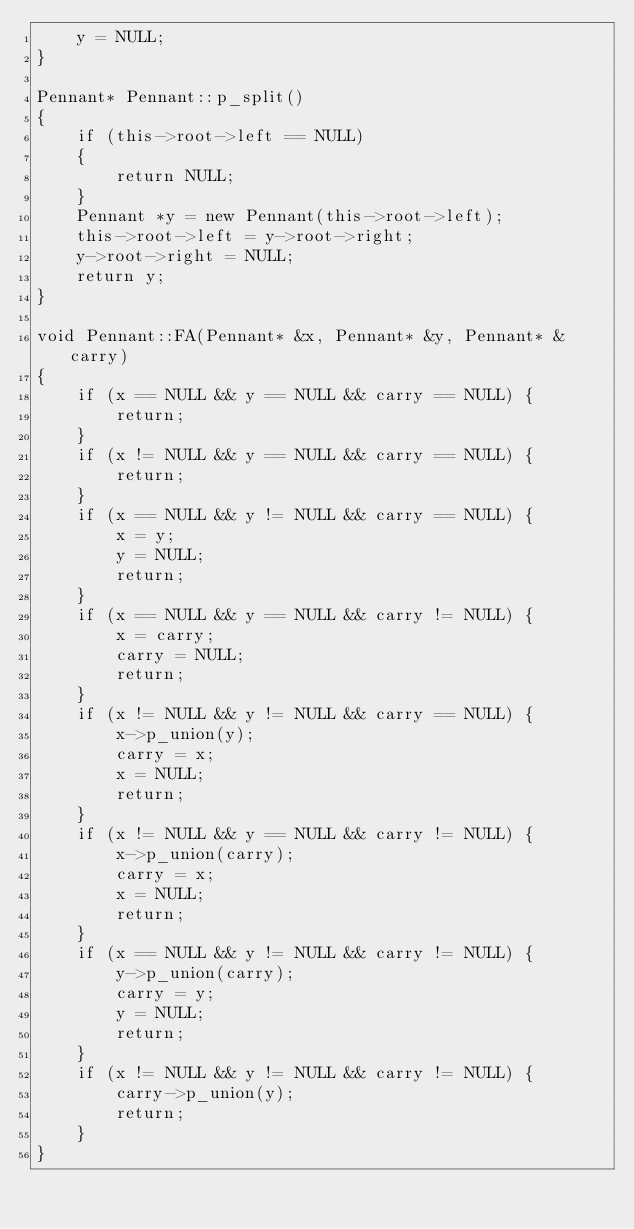<code> <loc_0><loc_0><loc_500><loc_500><_C++_>	y = NULL;
}

Pennant* Pennant::p_split()
{
	if (this->root->left == NULL)
	{
		return NULL;
	}
	Pennant *y = new Pennant(this->root->left);
	this->root->left = y->root->right;
	y->root->right = NULL;
	return y;
}

void Pennant::FA(Pennant* &x, Pennant* &y, Pennant* &carry)
{
	if (x == NULL && y == NULL && carry == NULL) {
		return;
	}
	if (x != NULL && y == NULL && carry == NULL) {
		return;
	}
	if (x == NULL && y != NULL && carry == NULL) {
		x = y;
		y = NULL;
		return;
	}
	if (x == NULL && y == NULL && carry != NULL) {
		x = carry;
		carry = NULL;
		return;
	}
	if (x != NULL && y != NULL && carry == NULL) {
		x->p_union(y);
		carry = x;
		x = NULL;
		return;
	}
	if (x != NULL && y == NULL && carry != NULL) {
		x->p_union(carry);
		carry = x;
		x = NULL;
		return;
	}
	if (x == NULL && y != NULL && carry != NULL) {
		y->p_union(carry);
		carry = y;
		y = NULL;
		return;
	}
	if (x != NULL && y != NULL && carry != NULL) {
		carry->p_union(y);
		return;
	}
}
</code> 